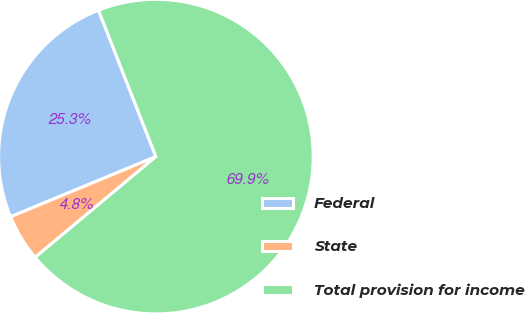Convert chart. <chart><loc_0><loc_0><loc_500><loc_500><pie_chart><fcel>Federal<fcel>State<fcel>Total provision for income<nl><fcel>25.3%<fcel>4.82%<fcel>69.88%<nl></chart> 